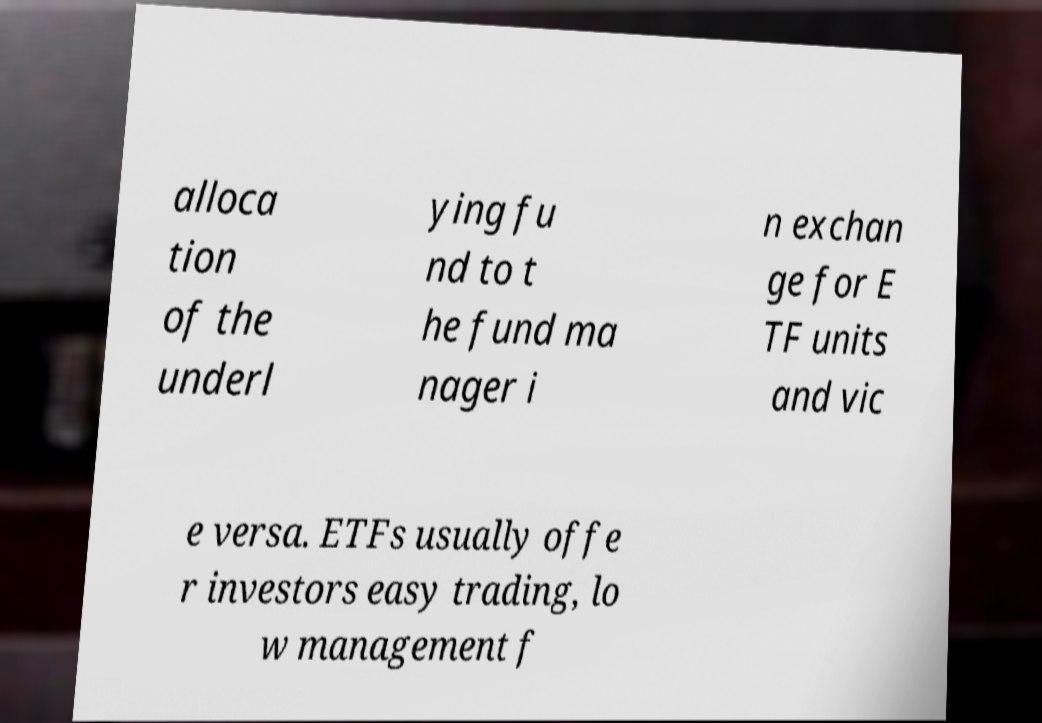Can you accurately transcribe the text from the provided image for me? alloca tion of the underl ying fu nd to t he fund ma nager i n exchan ge for E TF units and vic e versa. ETFs usually offe r investors easy trading, lo w management f 